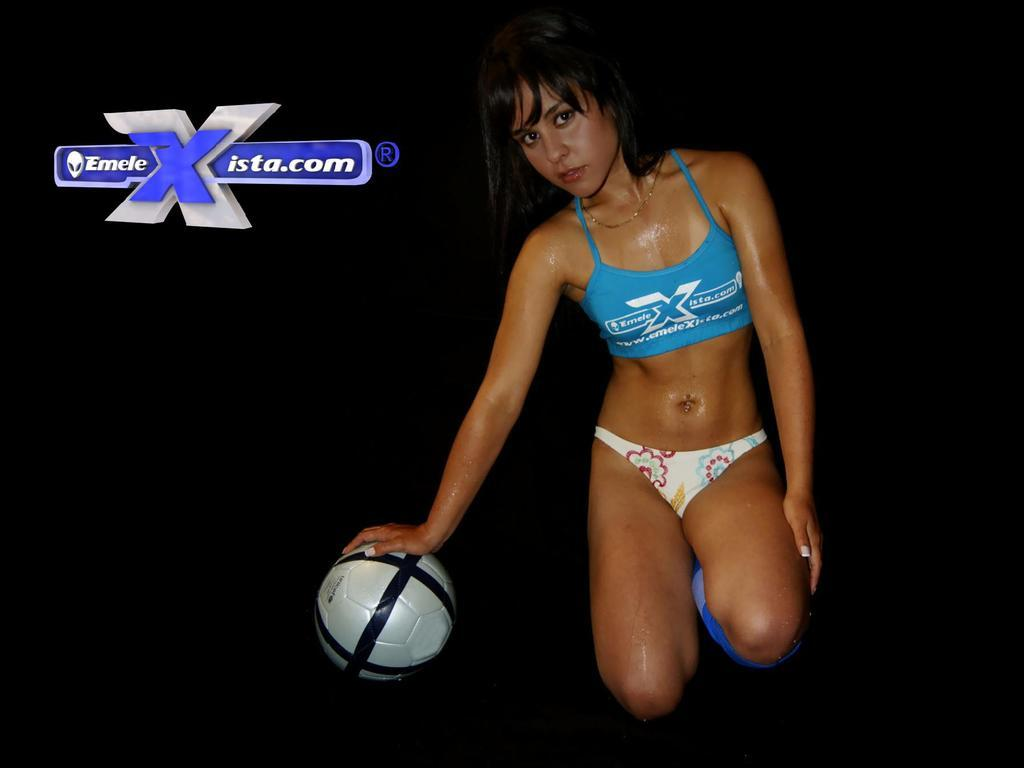Who is present in the image? There is a woman in the image. What is the woman doing in the image? The woman is kneeling on the floor. What object is the woman holding in the image? The woman is holding a ball. What else can be seen in the image besides the woman? There is a banner visible in the image. What type of toothbrush is the woman using in the image? There is no toothbrush present in the image. What is the woman doing with the brick in the image? There is no brick present in the image. What type of bun is the woman holding in the image? There is no bun present in the image; the woman is holding a ball. 